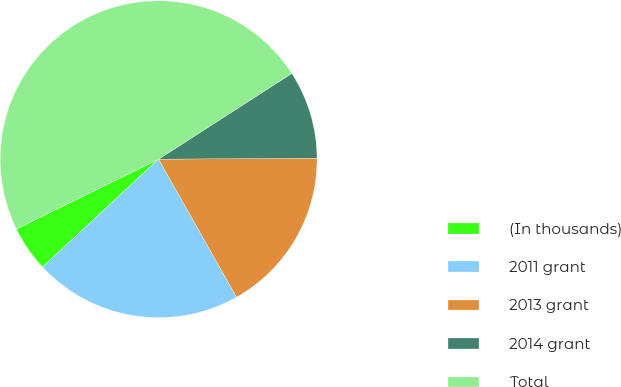<chart> <loc_0><loc_0><loc_500><loc_500><pie_chart><fcel>(In thousands)<fcel>2011 grant<fcel>2013 grant<fcel>2014 grant<fcel>Total<nl><fcel>4.65%<fcel>21.27%<fcel>16.92%<fcel>9.0%<fcel>48.15%<nl></chart> 